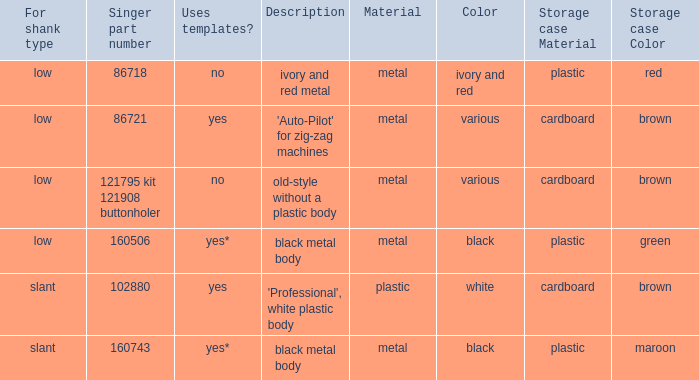What part number belongs to the singer buttonholer stored in a green plastic case? 160506.0. 